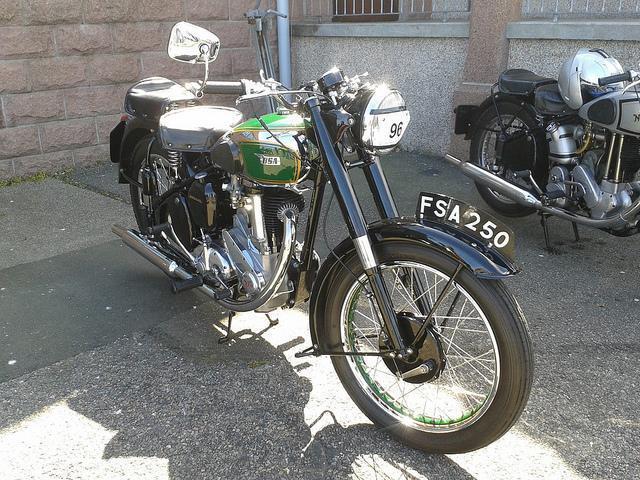How many motorcycles can be seen?
Give a very brief answer. 2. How many of the people are looking directly at the camera?
Give a very brief answer. 0. 